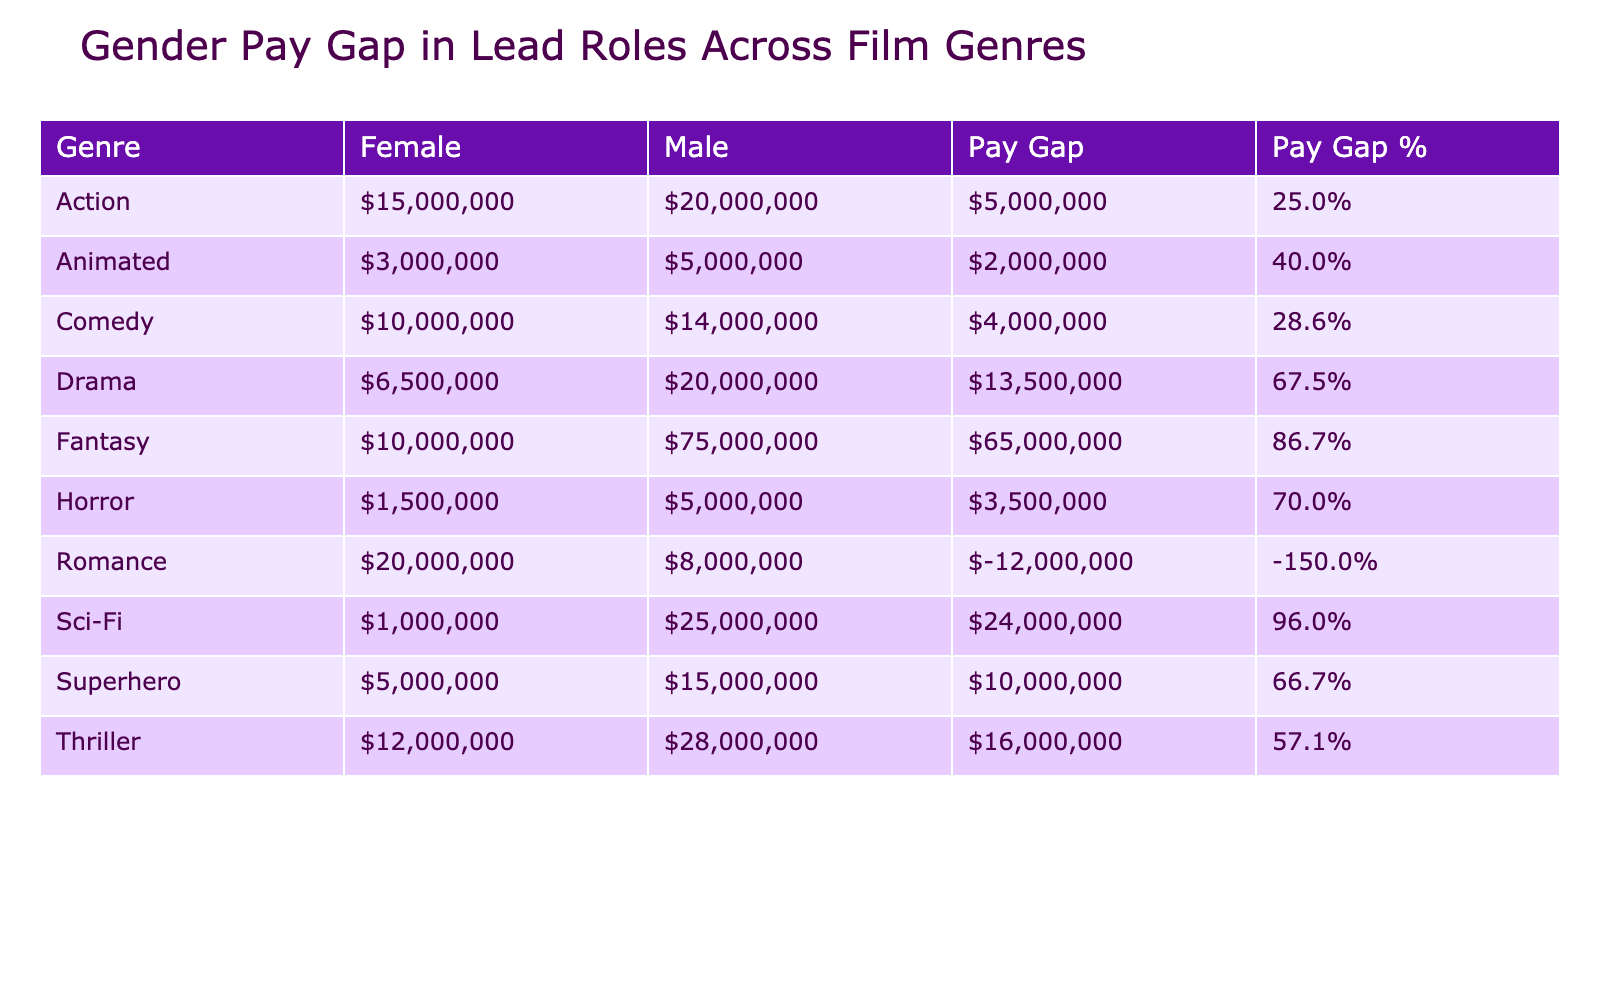What is the average salary for female leads in the Action genre? According to the table, there is one female lead in the Action genre, Scarlett Johansson, with a salary of $15,000,000. Therefore, the average salary for female leads in Action is the same as her salary, which is $15,000,000.
Answer: $15,000,000 Which genre has the highest average male salary? To find the genre with the highest average male salary, we look at the values for males in each genre. The averages are: Action ($20,000,000), Romance ($8,000,000), Comedy ($14,000,000), Drama ($20,000,000), Sci-Fi ($25,000,000), Thriller ($28,000,000), Fantasy ($75,000,000), Horror ($5,000,000), Animated ($5,000,000), and Superhero ($15,000,000). The highest average is in Fantasy with $75,000,000.
Answer: Fantasy Is there a gender pay gap in the Thriller genre? In the Thriller genre, the male average salary is $28,000,000 and the female average salary is $12,000,000. The difference is $28,000,000 - $12,000,000 = $16,000,000, which shows a clear gender pay gap.
Answer: Yes What is the percentage of the pay gap in the Sci-Fi genre? In the Sci-Fi genre, the male average salary is $25,000,000 and the female average salary is $1,000,000. The pay gap is calculated as ($25,000,000 - $1,000,000) / $25,000,000 * 100 = 96%. This means that the female salary is significantly lower compared to males in the Sci-Fi genre.
Answer: 96% Which genres show a pay gap greater than $10,000,000 for females? To determine this, we look at each genre's male and female averages and calculate the gaps. The genres with pay gaps greater than $10,000,000 are Action ($15,000,000), Thriller ($16,000,000), and Sci-Fi ($24,000,000).
Answer: Action, Thriller, Sci-Fi 